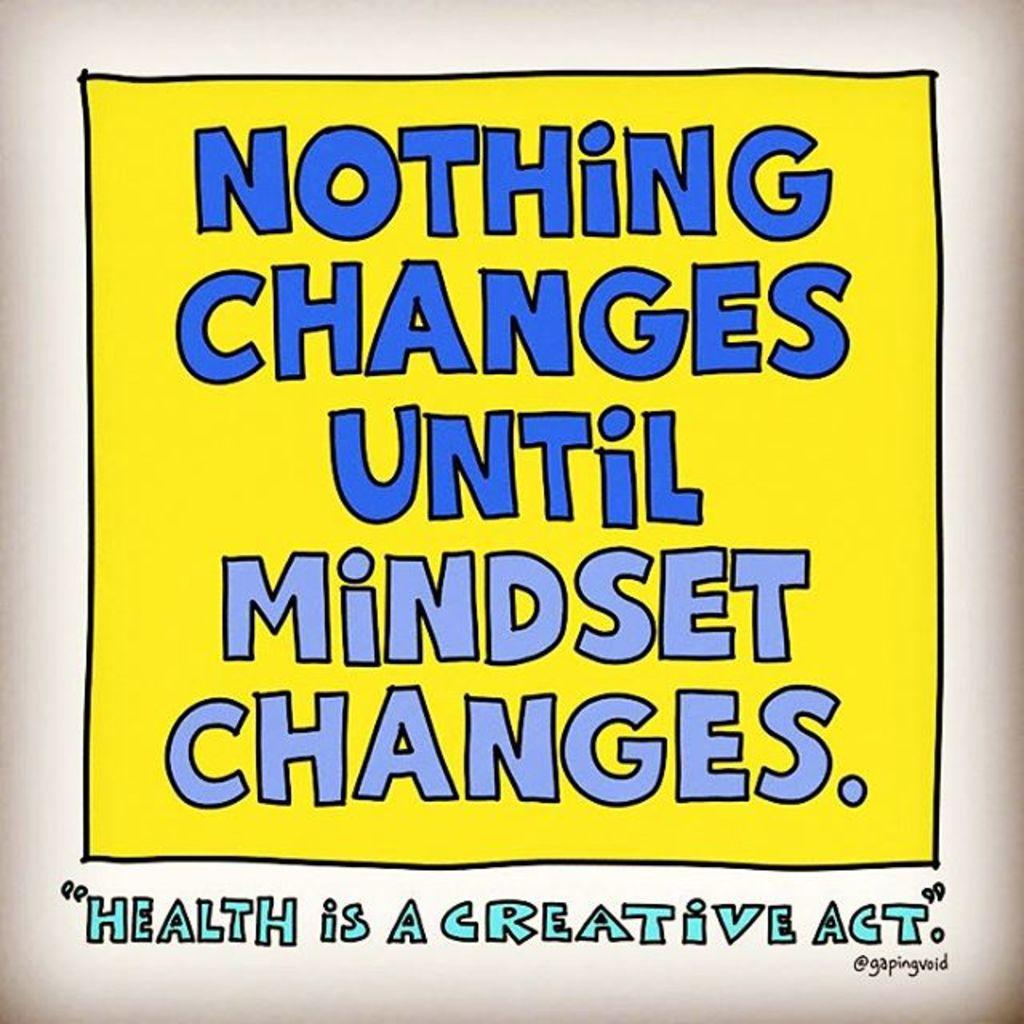<image>
Relay a brief, clear account of the picture shown. Yellow background with blue wording that says "Nothign changes until mindset changes". 